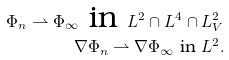<formula> <loc_0><loc_0><loc_500><loc_500>\Phi _ { n } \rightharpoonup \Phi _ { \infty } \text { in } L ^ { 2 } \cap L ^ { 4 } \cap L ^ { 2 } _ { V } \\ \nabla \Phi _ { n } \rightharpoonup \nabla \Phi _ { \infty } \text { in } L ^ { 2 } .</formula> 